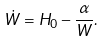<formula> <loc_0><loc_0><loc_500><loc_500>\dot { W } = H _ { 0 } - \frac { \alpha } { W } .</formula> 